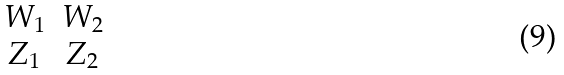<formula> <loc_0><loc_0><loc_500><loc_500>\begin{matrix} W _ { 1 } & W _ { 2 } \\ Z _ { 1 } & Z _ { 2 } \end{matrix}</formula> 